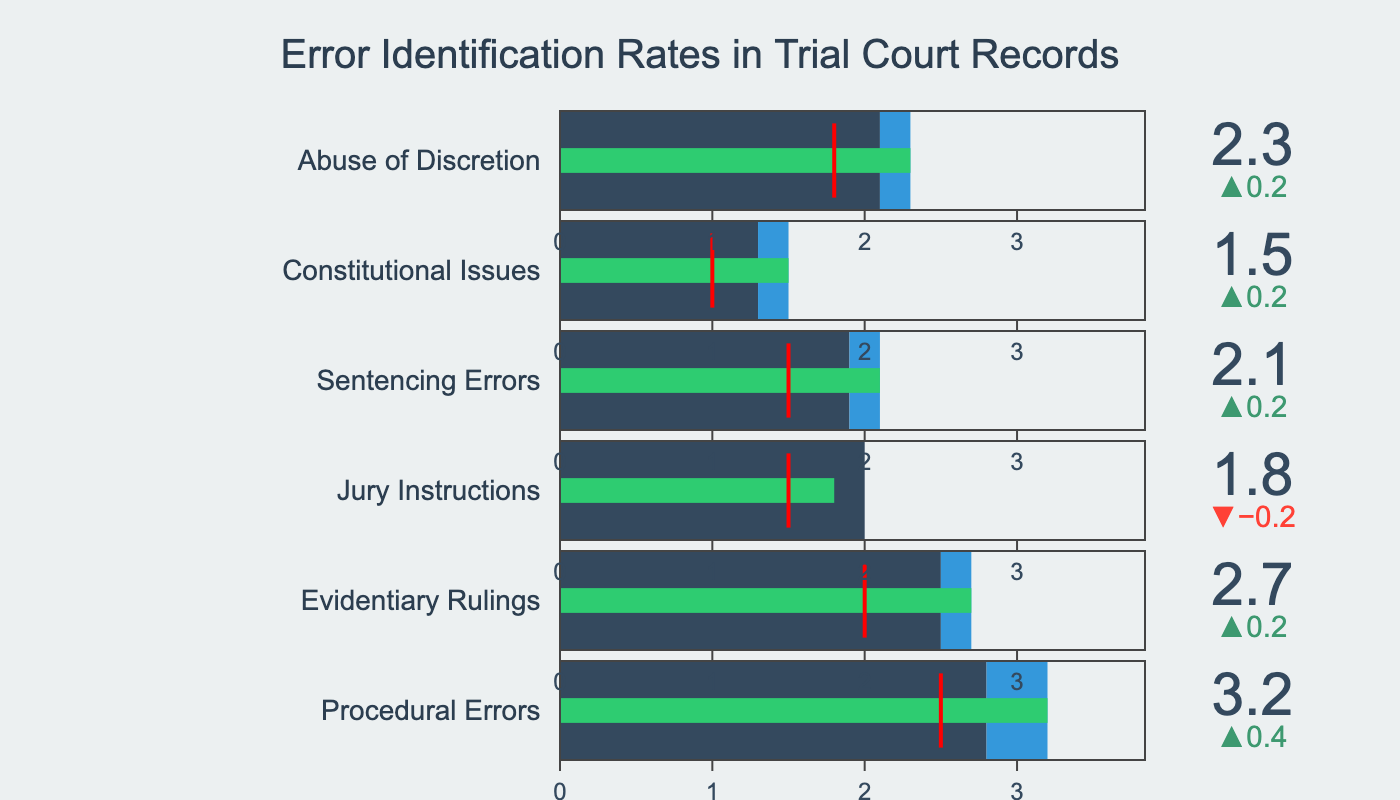What's the title of the figure? The title of a figure is generally located at the top of the visual. In this case, the title is "Error Identification Rates in Trial Court Records".
Answer: Error Identification Rates in Trial Court Records How many categories of errors are reported in the figure? Each bullet chart represents a different category of error. By counting the number of bullet charts, we find there are six categories listed.
Answer: Six What category has the highest actual error identification rate? To find this, look at the "Actual" values for each category and compare. "Procedural Errors" has the highest value of 3.2.
Answer: Procedural Errors What is the target error identification rate for "Sentencing Errors"? Locate the "Sentencing Errors" bullet chart and identify the red threshold marker. The value displayed is 1.5.
Answer: 1.5 Which category is closest to achieving its target error identification rate? To determine this, calculate the difference between the "Actual" rate and the "Target" rate for each category. "Constitutional Issues" has the smallest gap (1.5 - 1.0 = 0.5).
Answer: Constitutional Issues How much higher is the actual error identification rate for "Evidentiary Rulings" compared to its comparative rate? Subtract the "Comparative" rate from the "Actual" rate for "Evidentiary Rulings" (2.7 - 2.5).
Answer: 0.2 Which category shows the largest increase in error identification rate compared to the historical average? Calculate the differences between "Actual" and "Comparative" for each category, then identify the largest value. "Procedural Errors" has the largest increase (3.2 - 2.8 = 0.4).
Answer: Procedural Errors In which category is the "Actual" error identification rate below the "Comparative" error identification rate? Compare the "Actual" and "Comparative" rates for each category. For "Jury Instructions," the "Actual" rate (1.8) is below the "Comparative" rate (2.0).
Answer: Jury Instructions What's the average actual error rate across all categories? Sum the actual error rates and divide by the number of categories: (3.2 + 2.7 + 1.8 + 2.1 + 1.5 + 2.3) / 6 = 2.27
Answer: 2.27 